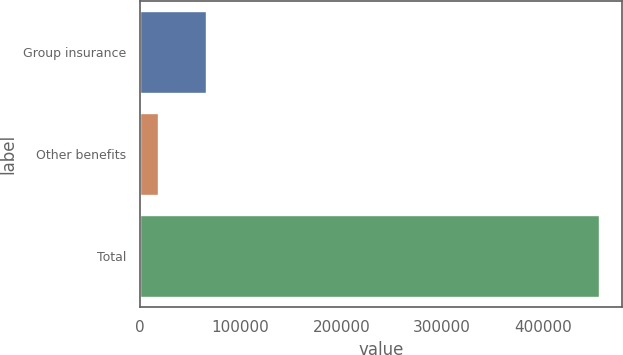<chart> <loc_0><loc_0><loc_500><loc_500><bar_chart><fcel>Group insurance<fcel>Other benefits<fcel>Total<nl><fcel>65872<fcel>18422<fcel>455690<nl></chart> 